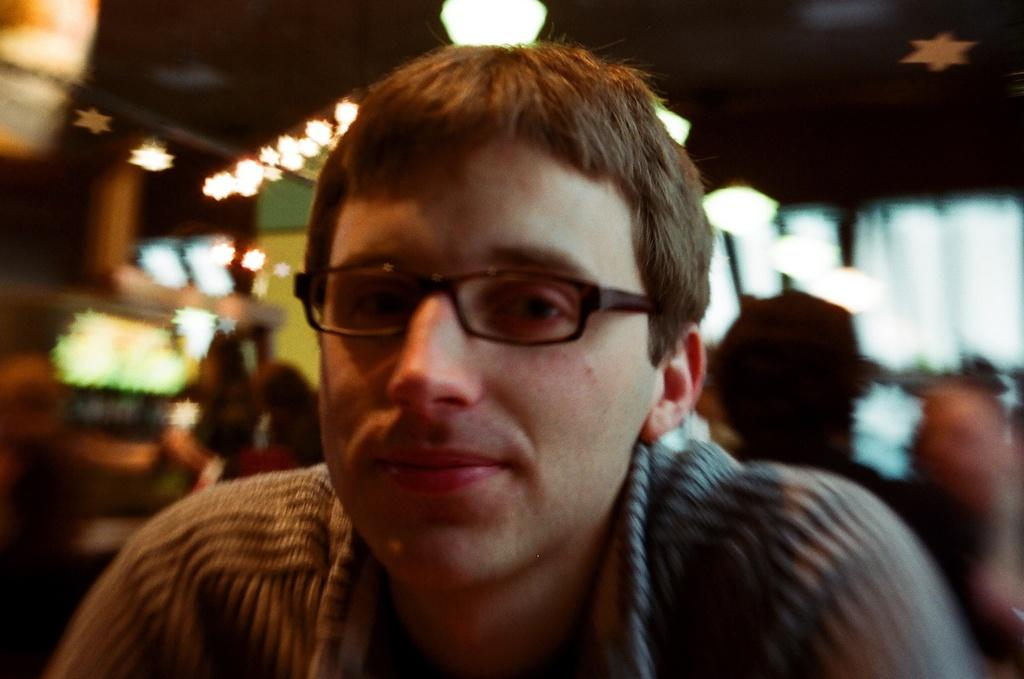Who is the main subject in the image? There is a person highlighted in the image. What is the appearance of the background in the image? The background is blurred. Can you describe the people in the background? There are people visible in the background. What is the structure with lights in the image? The roof with lights is present in the image. What else can be seen in the image besides the person and the background? There are objects visible in the image. What type of game is being played by the person in the image? There is no game being played in the image; it only shows a person with a blurred background and a roof with lights. What is the purpose of the pail in the image? There is no pail present in the image. 